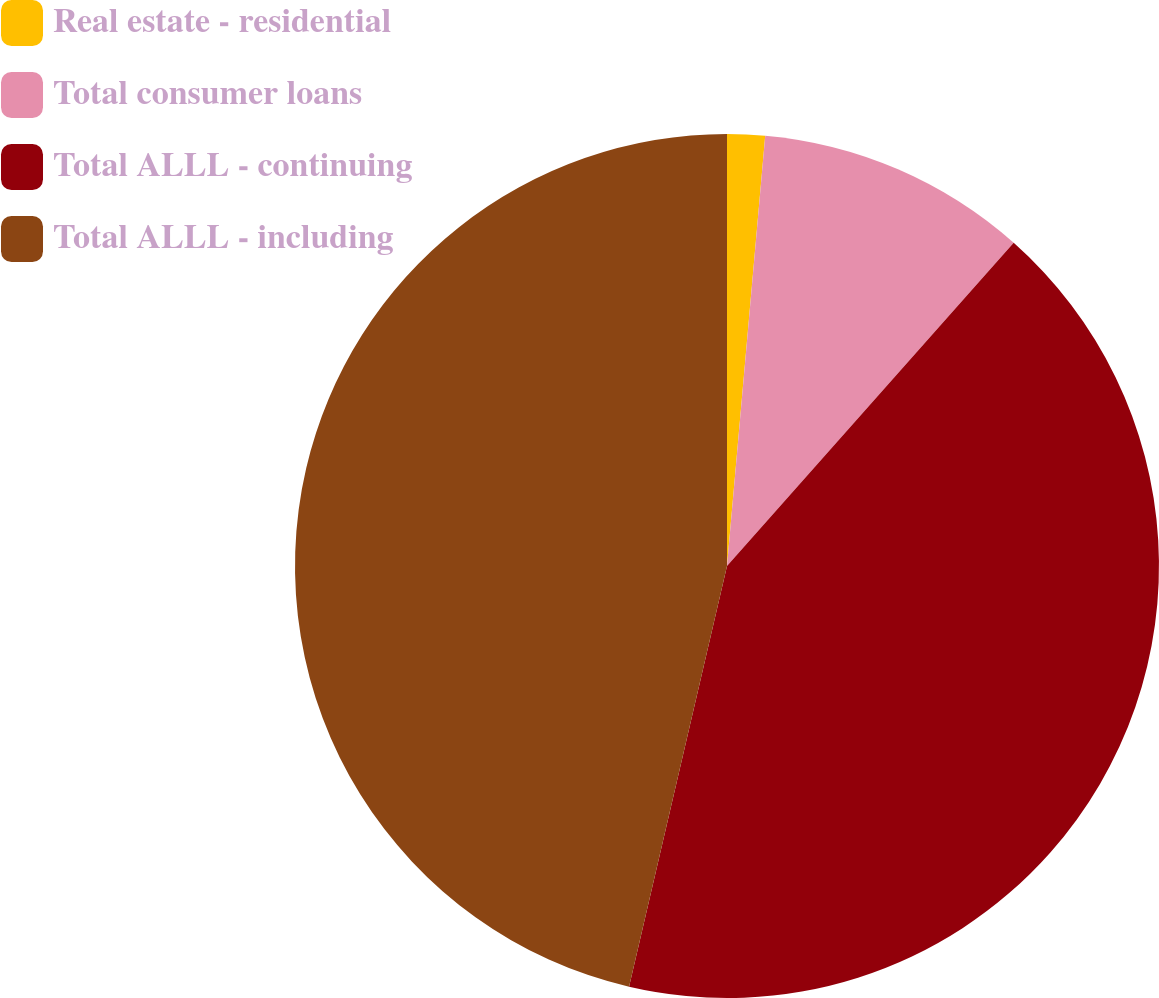<chart> <loc_0><loc_0><loc_500><loc_500><pie_chart><fcel>Real estate - residential<fcel>Total consumer loans<fcel>Total ALLL - continuing<fcel>Total ALLL - including<nl><fcel>1.41%<fcel>10.14%<fcel>42.09%<fcel>46.36%<nl></chart> 